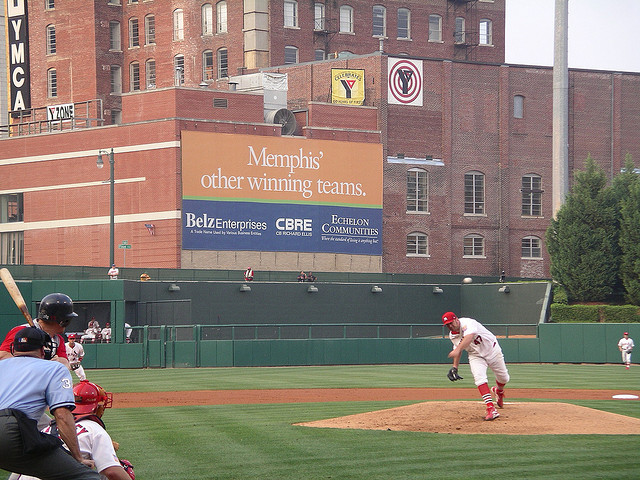Please identify all text content in this image. Memphis' other winning teams. CBRE 6 COMMUNITIES ECHELON Enterprises Belz Y ZONE OYMCA 